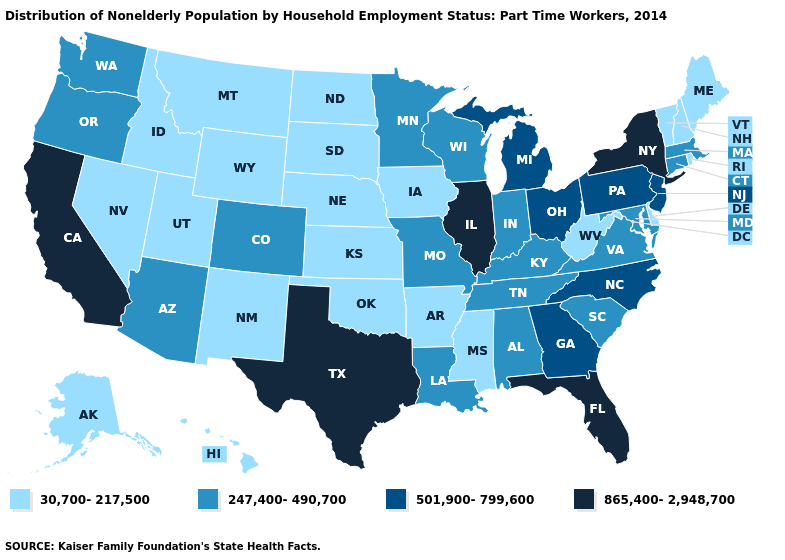Which states have the lowest value in the USA?
Quick response, please. Alaska, Arkansas, Delaware, Hawaii, Idaho, Iowa, Kansas, Maine, Mississippi, Montana, Nebraska, Nevada, New Hampshire, New Mexico, North Dakota, Oklahoma, Rhode Island, South Dakota, Utah, Vermont, West Virginia, Wyoming. What is the value of North Carolina?
Keep it brief. 501,900-799,600. Which states have the highest value in the USA?
Concise answer only. California, Florida, Illinois, New York, Texas. What is the value of South Dakota?
Write a very short answer. 30,700-217,500. Which states have the lowest value in the South?
Write a very short answer. Arkansas, Delaware, Mississippi, Oklahoma, West Virginia. Among the states that border Idaho , which have the highest value?
Be succinct. Oregon, Washington. What is the value of Arkansas?
Give a very brief answer. 30,700-217,500. Which states have the lowest value in the MidWest?
Write a very short answer. Iowa, Kansas, Nebraska, North Dakota, South Dakota. Does West Virginia have the same value as Connecticut?
Short answer required. No. Name the states that have a value in the range 247,400-490,700?
Give a very brief answer. Alabama, Arizona, Colorado, Connecticut, Indiana, Kentucky, Louisiana, Maryland, Massachusetts, Minnesota, Missouri, Oregon, South Carolina, Tennessee, Virginia, Washington, Wisconsin. What is the highest value in the Northeast ?
Quick response, please. 865,400-2,948,700. Does Missouri have the lowest value in the MidWest?
Quick response, please. No. Which states hav the highest value in the MidWest?
Short answer required. Illinois. Name the states that have a value in the range 247,400-490,700?
Short answer required. Alabama, Arizona, Colorado, Connecticut, Indiana, Kentucky, Louisiana, Maryland, Massachusetts, Minnesota, Missouri, Oregon, South Carolina, Tennessee, Virginia, Washington, Wisconsin. What is the value of Wyoming?
Quick response, please. 30,700-217,500. 